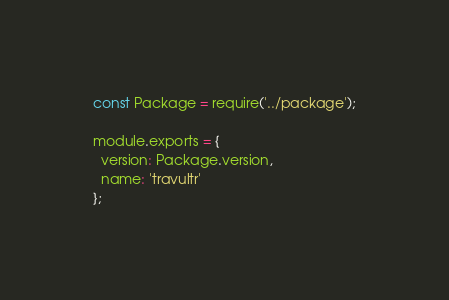<code> <loc_0><loc_0><loc_500><loc_500><_JavaScript_>const Package = require('../package');

module.exports = {
  version: Package.version,
  name: 'travultr'
};
</code> 